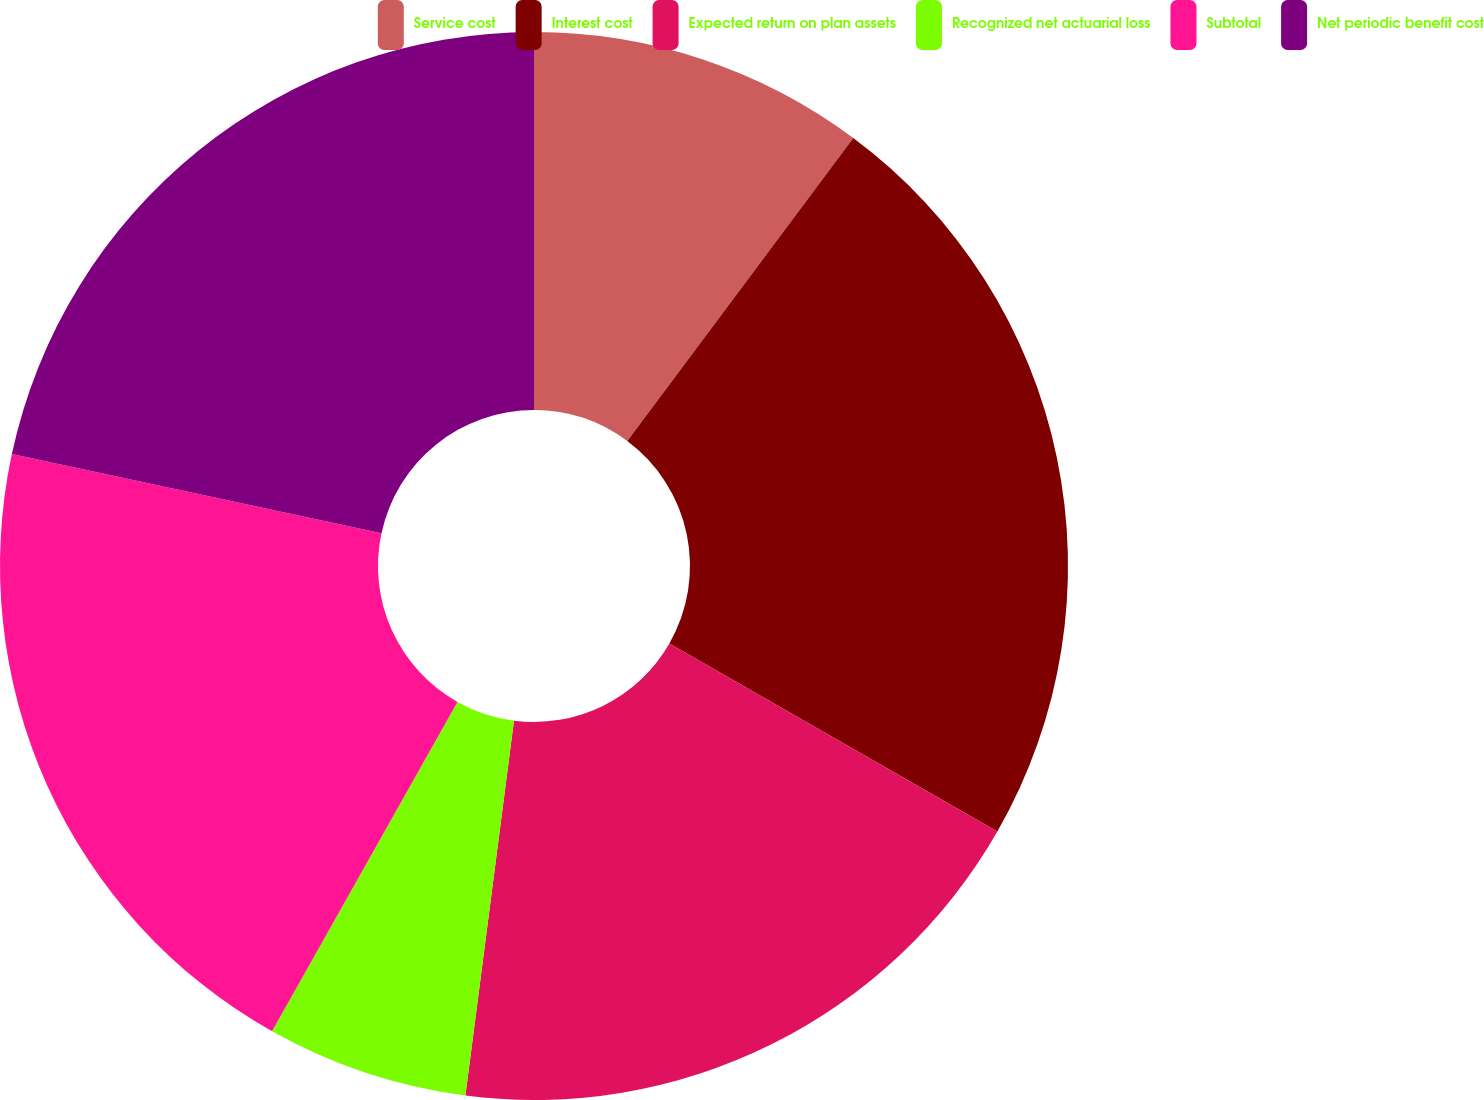Convert chart. <chart><loc_0><loc_0><loc_500><loc_500><pie_chart><fcel>Service cost<fcel>Interest cost<fcel>Expected return on plan assets<fcel>Recognized net actuarial loss<fcel>Subtotal<fcel>Net periodic benefit cost<nl><fcel>10.2%<fcel>23.08%<fcel>18.77%<fcel>6.11%<fcel>20.2%<fcel>21.64%<nl></chart> 